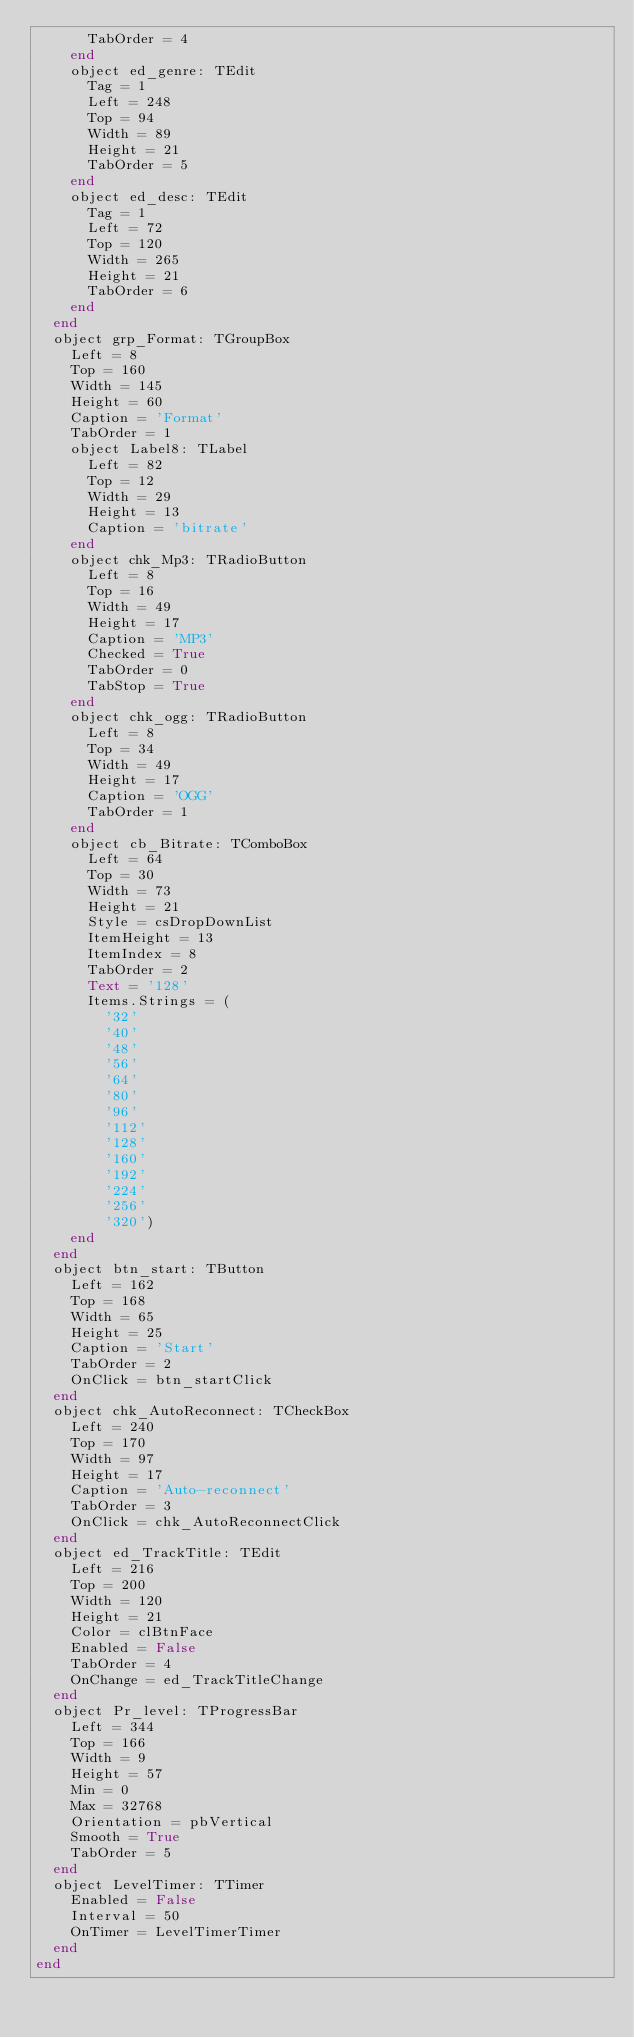<code> <loc_0><loc_0><loc_500><loc_500><_Pascal_>      TabOrder = 4
    end
    object ed_genre: TEdit
      Tag = 1
      Left = 248
      Top = 94
      Width = 89
      Height = 21
      TabOrder = 5
    end
    object ed_desc: TEdit
      Tag = 1
      Left = 72
      Top = 120
      Width = 265
      Height = 21
      TabOrder = 6
    end
  end
  object grp_Format: TGroupBox
    Left = 8
    Top = 160
    Width = 145
    Height = 60
    Caption = 'Format'
    TabOrder = 1
    object Label8: TLabel
      Left = 82
      Top = 12
      Width = 29
      Height = 13
      Caption = 'bitrate'
    end
    object chk_Mp3: TRadioButton
      Left = 8
      Top = 16
      Width = 49
      Height = 17
      Caption = 'MP3'
      Checked = True
      TabOrder = 0
      TabStop = True
    end
    object chk_ogg: TRadioButton
      Left = 8
      Top = 34
      Width = 49
      Height = 17
      Caption = 'OGG'
      TabOrder = 1
    end
    object cb_Bitrate: TComboBox
      Left = 64
      Top = 30
      Width = 73
      Height = 21
      Style = csDropDownList
      ItemHeight = 13
      ItemIndex = 8
      TabOrder = 2
      Text = '128'
      Items.Strings = (
        '32'
        '40'
        '48'
        '56'
        '64'
        '80'
        '96'
        '112'
        '128'
        '160'
        '192'
        '224'
        '256'
        '320')
    end
  end
  object btn_start: TButton
    Left = 162
    Top = 168
    Width = 65
    Height = 25
    Caption = 'Start'
    TabOrder = 2
    OnClick = btn_startClick
  end
  object chk_AutoReconnect: TCheckBox
    Left = 240
    Top = 170
    Width = 97
    Height = 17
    Caption = 'Auto-reconnect'
    TabOrder = 3
    OnClick = chk_AutoReconnectClick
  end
  object ed_TrackTitle: TEdit
    Left = 216
    Top = 200
    Width = 120
    Height = 21
    Color = clBtnFace
    Enabled = False
    TabOrder = 4
    OnChange = ed_TrackTitleChange
  end
  object Pr_level: TProgressBar
    Left = 344
    Top = 166
    Width = 9
    Height = 57
    Min = 0
    Max = 32768
    Orientation = pbVertical
    Smooth = True
    TabOrder = 5
  end
  object LevelTimer: TTimer
    Enabled = False
    Interval = 50
    OnTimer = LevelTimerTimer
  end
end
</code> 